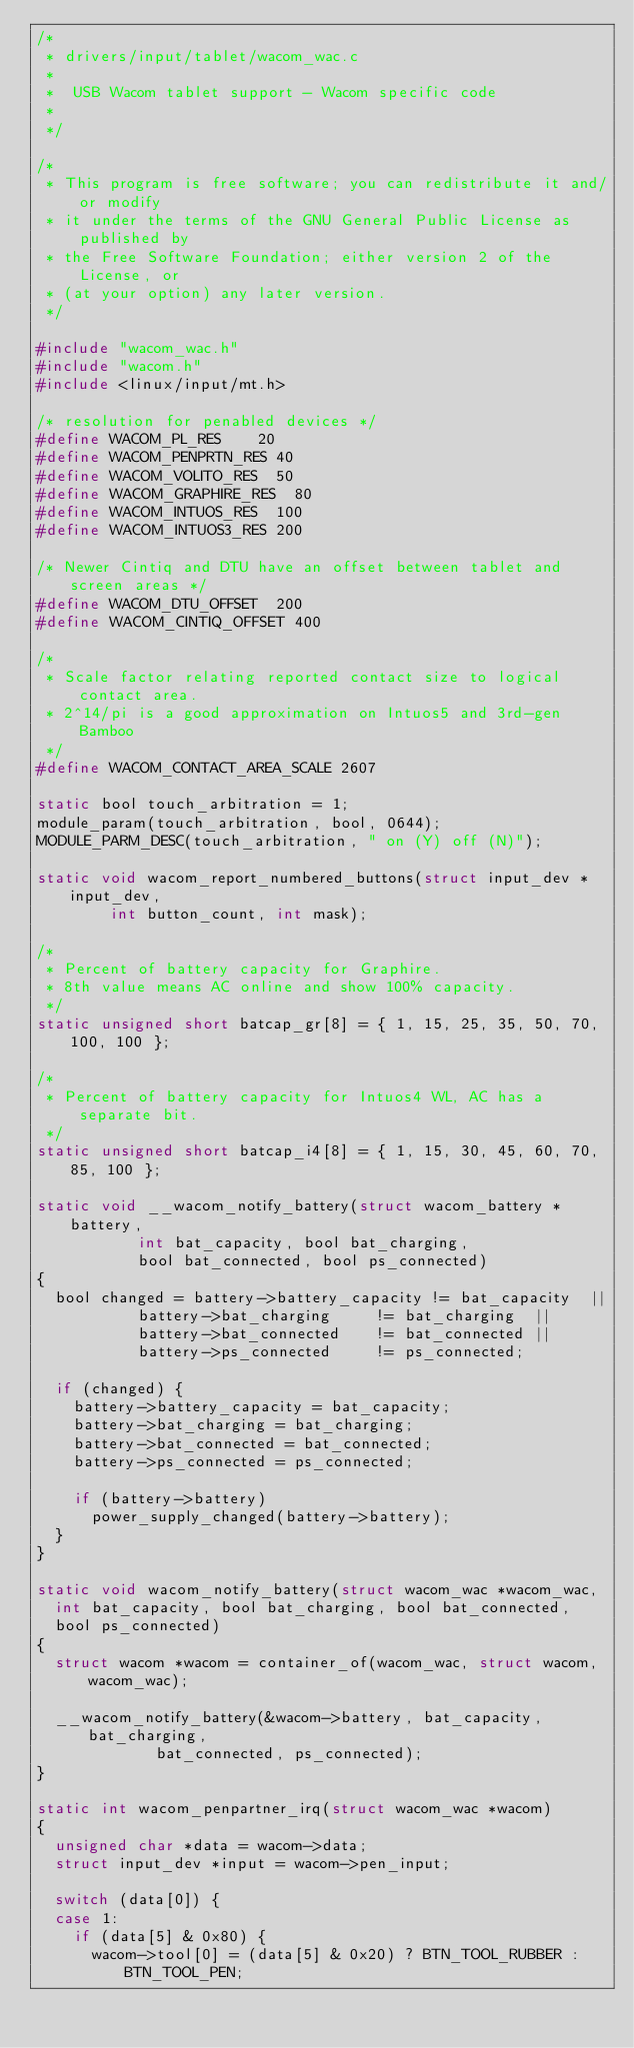Convert code to text. <code><loc_0><loc_0><loc_500><loc_500><_C_>/*
 * drivers/input/tablet/wacom_wac.c
 *
 *  USB Wacom tablet support - Wacom specific code
 *
 */

/*
 * This program is free software; you can redistribute it and/or modify
 * it under the terms of the GNU General Public License as published by
 * the Free Software Foundation; either version 2 of the License, or
 * (at your option) any later version.
 */

#include "wacom_wac.h"
#include "wacom.h"
#include <linux/input/mt.h>

/* resolution for penabled devices */
#define WACOM_PL_RES		20
#define WACOM_PENPRTN_RES	40
#define WACOM_VOLITO_RES	50
#define WACOM_GRAPHIRE_RES	80
#define WACOM_INTUOS_RES	100
#define WACOM_INTUOS3_RES	200

/* Newer Cintiq and DTU have an offset between tablet and screen areas */
#define WACOM_DTU_OFFSET	200
#define WACOM_CINTIQ_OFFSET	400

/*
 * Scale factor relating reported contact size to logical contact area.
 * 2^14/pi is a good approximation on Intuos5 and 3rd-gen Bamboo
 */
#define WACOM_CONTACT_AREA_SCALE 2607

static bool touch_arbitration = 1;
module_param(touch_arbitration, bool, 0644);
MODULE_PARM_DESC(touch_arbitration, " on (Y) off (N)");

static void wacom_report_numbered_buttons(struct input_dev *input_dev,
				int button_count, int mask);

/*
 * Percent of battery capacity for Graphire.
 * 8th value means AC online and show 100% capacity.
 */
static unsigned short batcap_gr[8] = { 1, 15, 25, 35, 50, 70, 100, 100 };

/*
 * Percent of battery capacity for Intuos4 WL, AC has a separate bit.
 */
static unsigned short batcap_i4[8] = { 1, 15, 30, 45, 60, 70, 85, 100 };

static void __wacom_notify_battery(struct wacom_battery *battery,
				   int bat_capacity, bool bat_charging,
				   bool bat_connected, bool ps_connected)
{
	bool changed = battery->battery_capacity != bat_capacity  ||
		       battery->bat_charging     != bat_charging  ||
		       battery->bat_connected    != bat_connected ||
		       battery->ps_connected     != ps_connected;

	if (changed) {
		battery->battery_capacity = bat_capacity;
		battery->bat_charging = bat_charging;
		battery->bat_connected = bat_connected;
		battery->ps_connected = ps_connected;

		if (battery->battery)
			power_supply_changed(battery->battery);
	}
}

static void wacom_notify_battery(struct wacom_wac *wacom_wac,
	int bat_capacity, bool bat_charging, bool bat_connected,
	bool ps_connected)
{
	struct wacom *wacom = container_of(wacom_wac, struct wacom, wacom_wac);

	__wacom_notify_battery(&wacom->battery, bat_capacity, bat_charging,
			       bat_connected, ps_connected);
}

static int wacom_penpartner_irq(struct wacom_wac *wacom)
{
	unsigned char *data = wacom->data;
	struct input_dev *input = wacom->pen_input;

	switch (data[0]) {
	case 1:
		if (data[5] & 0x80) {
			wacom->tool[0] = (data[5] & 0x20) ? BTN_TOOL_RUBBER : BTN_TOOL_PEN;</code> 